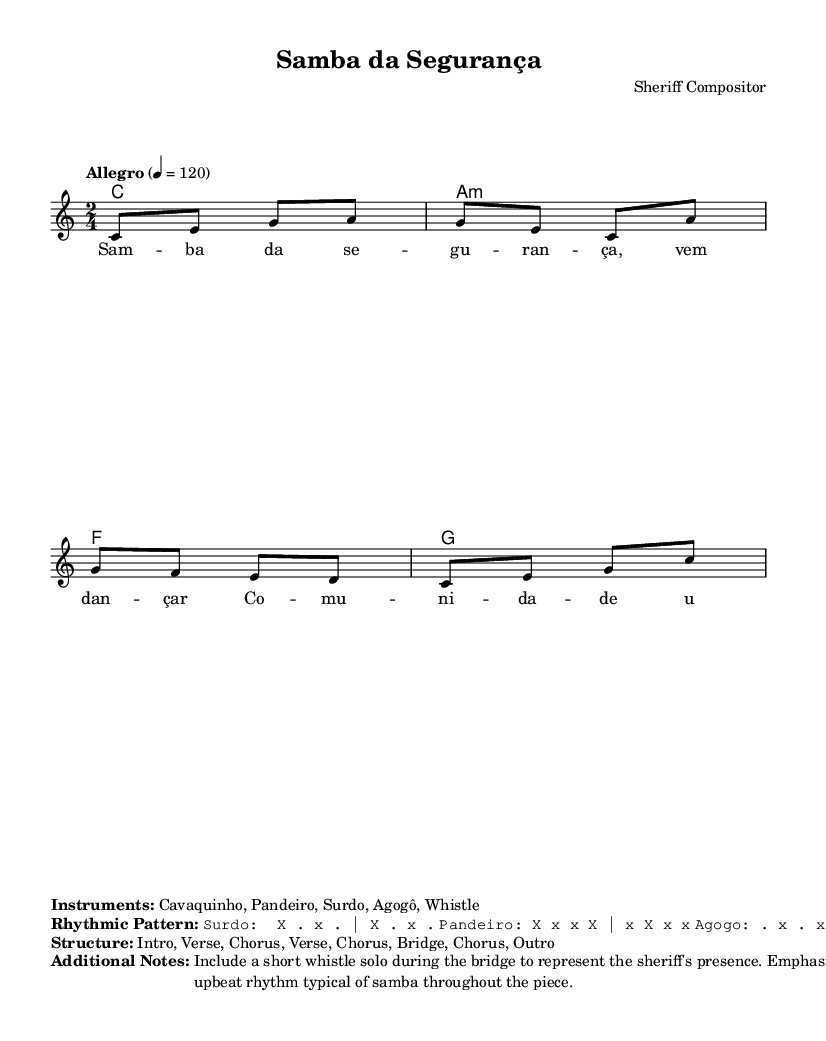what is the key signature of this music? The key signature is indicated at the beginning of the score. In this case, it is C major, which has no sharps or flats.
Answer: C major what is the time signature of this piece? The time signature is shown next to the key signature at the start of the score. Here, it is 2/4, meaning there are two beats in each measure.
Answer: 2/4 what is the tempo marking for this composition? The tempo is specified in the score, where it states "Allegro" with a metronome marking of quarter note equals 120. This means the piece should be played at a fast pace.
Answer: Allegro 4 = 120 how many measures are in the verse section? To find the number of measures in the verse, we look at the lyrics and the corresponding music notation. The verse has two measures of music that match with the lyrics "Samba da segurança."
Answer: 2 what instruments are featured in this samba piece? The instruments are listed in the score under the "Instruments" markup section. They include Cavaquinho, Pandeiro, Surdo, Agogô, and Whistle, reflecting traditional samba instrumentation.
Answer: Cavaquinho, Pandeiro, Surdo, Agogô, Whistle 